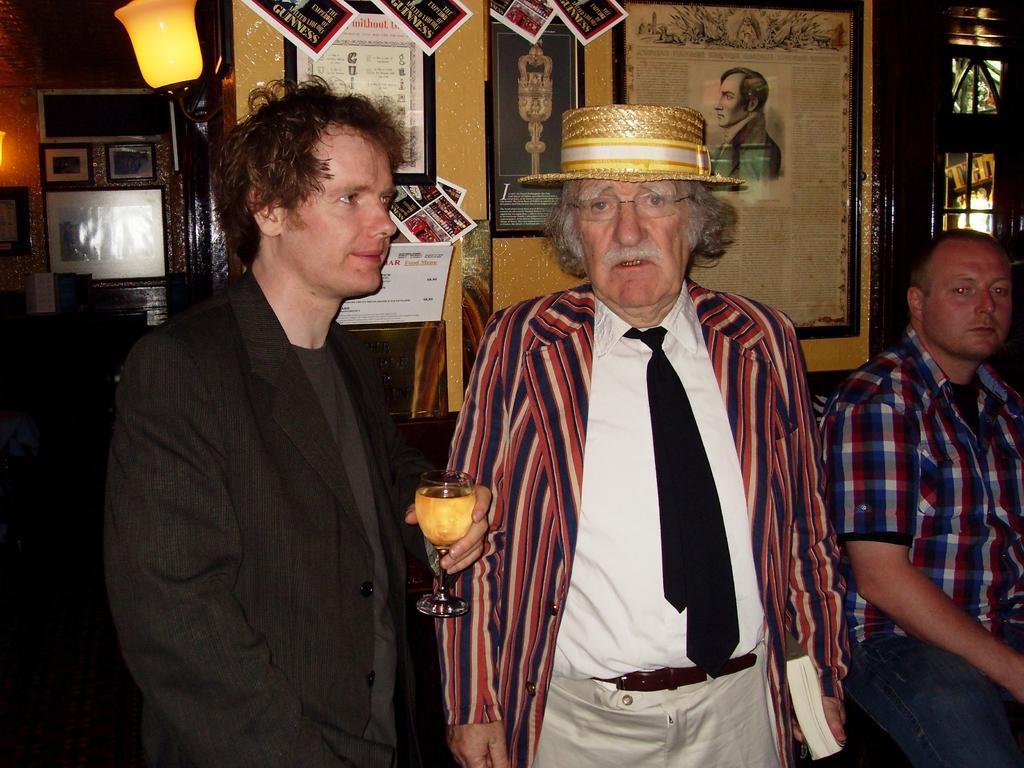In one or two sentences, can you explain what this image depicts? In this image in front there are two people holding the glass and a book. Beside them there is another person sitting on the chair. In the background of the image there are photo frames, posters attached to the wall. There are lights. 